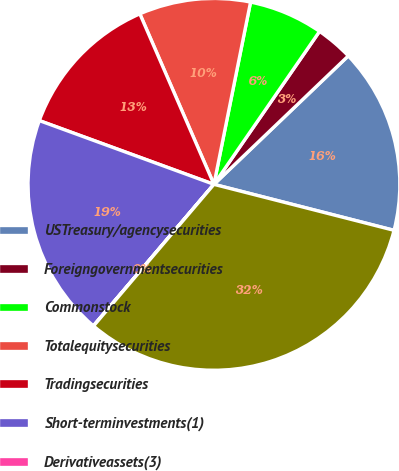Convert chart. <chart><loc_0><loc_0><loc_500><loc_500><pie_chart><fcel>USTreasury/agencysecurities<fcel>Foreigngovernmentsecurities<fcel>Commonstock<fcel>Totalequitysecurities<fcel>Tradingsecurities<fcel>Short-terminvestments(1)<fcel>Derivativeassets(3)<fcel>Separateaccountassets(6)<nl><fcel>16.12%<fcel>3.24%<fcel>6.46%<fcel>9.68%<fcel>12.9%<fcel>19.34%<fcel>0.02%<fcel>32.23%<nl></chart> 